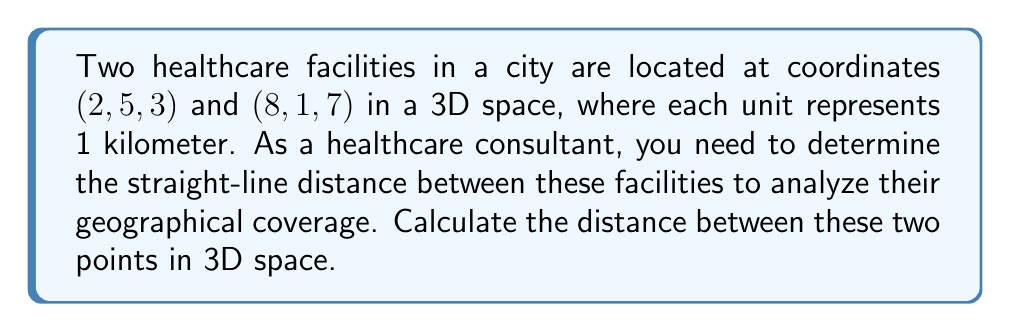Provide a solution to this math problem. To find the distance between two points in 3D space, we use the distance formula derived from the Pythagorean theorem:

$$d = \sqrt{(x_2 - x_1)^2 + (y_2 - y_1)^2 + (z_2 - z_1)^2}$$

Where $(x_1, y_1, z_1)$ is the first point and $(x_2, y_2, z_2)$ is the second point.

Let's substitute the given coordinates:
$(x_1, y_1, z_1) = (2, 5, 3)$
$(x_2, y_2, z_2) = (8, 1, 7)$

Now, let's calculate each term inside the square root:

1. $(x_2 - x_1)^2 = (8 - 2)^2 = 6^2 = 36$
2. $(y_2 - y_1)^2 = (1 - 5)^2 = (-4)^2 = 16$
3. $(z_2 - z_1)^2 = (7 - 3)^2 = 4^2 = 16$

Sum these terms:
$$36 + 16 + 16 = 68$$

Now, take the square root:
$$d = \sqrt{68}$$

Simplify:
$$d = 2\sqrt{17}$$

Since each unit represents 1 kilometer, the distance between the two healthcare facilities is $2\sqrt{17}$ kilometers.
Answer: $2\sqrt{17}$ km 